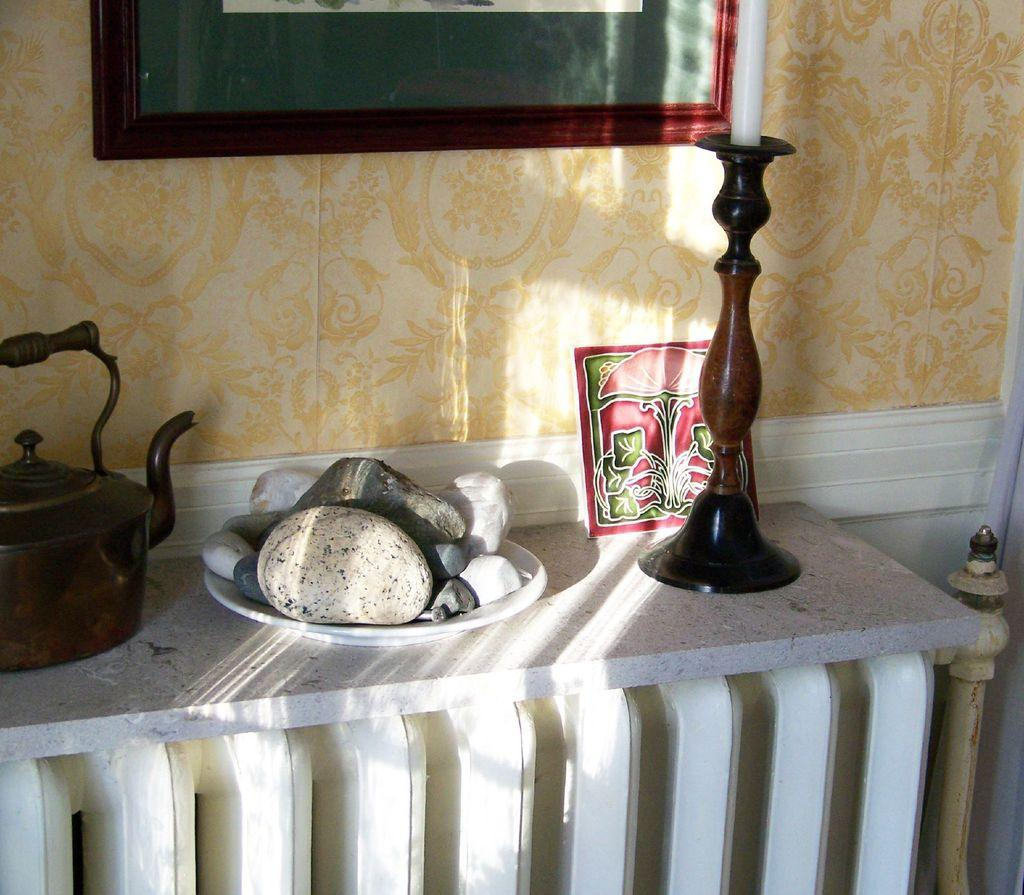What is the main object in the image? There is a kettle in the image. What else can be seen on a plate in the image? There are pebbles in a plate in the image. What type of furniture is present in the image? There is a candle stand in the image. What is placed on a platform in the image? There is a frame on a platform in the image. What can be seen in the background of the image? There is a wall and a truncated frame in the background of the image. How many cars are parked in front of the wall in the image? There are no cars present in the image; it only features a kettle, pebbles, a candle stand, a frame, a wall, and a truncated frame. 